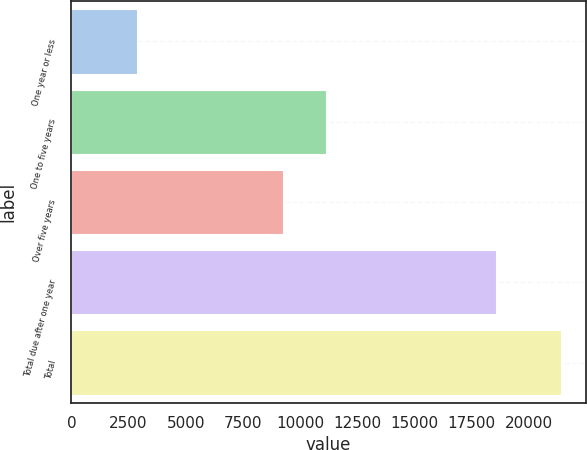Convert chart to OTSL. <chart><loc_0><loc_0><loc_500><loc_500><bar_chart><fcel>One year or less<fcel>One to five years<fcel>Over five years<fcel>Total due after one year<fcel>Total<nl><fcel>2848.8<fcel>11113.6<fcel>9258<fcel>18556.1<fcel>21404.9<nl></chart> 